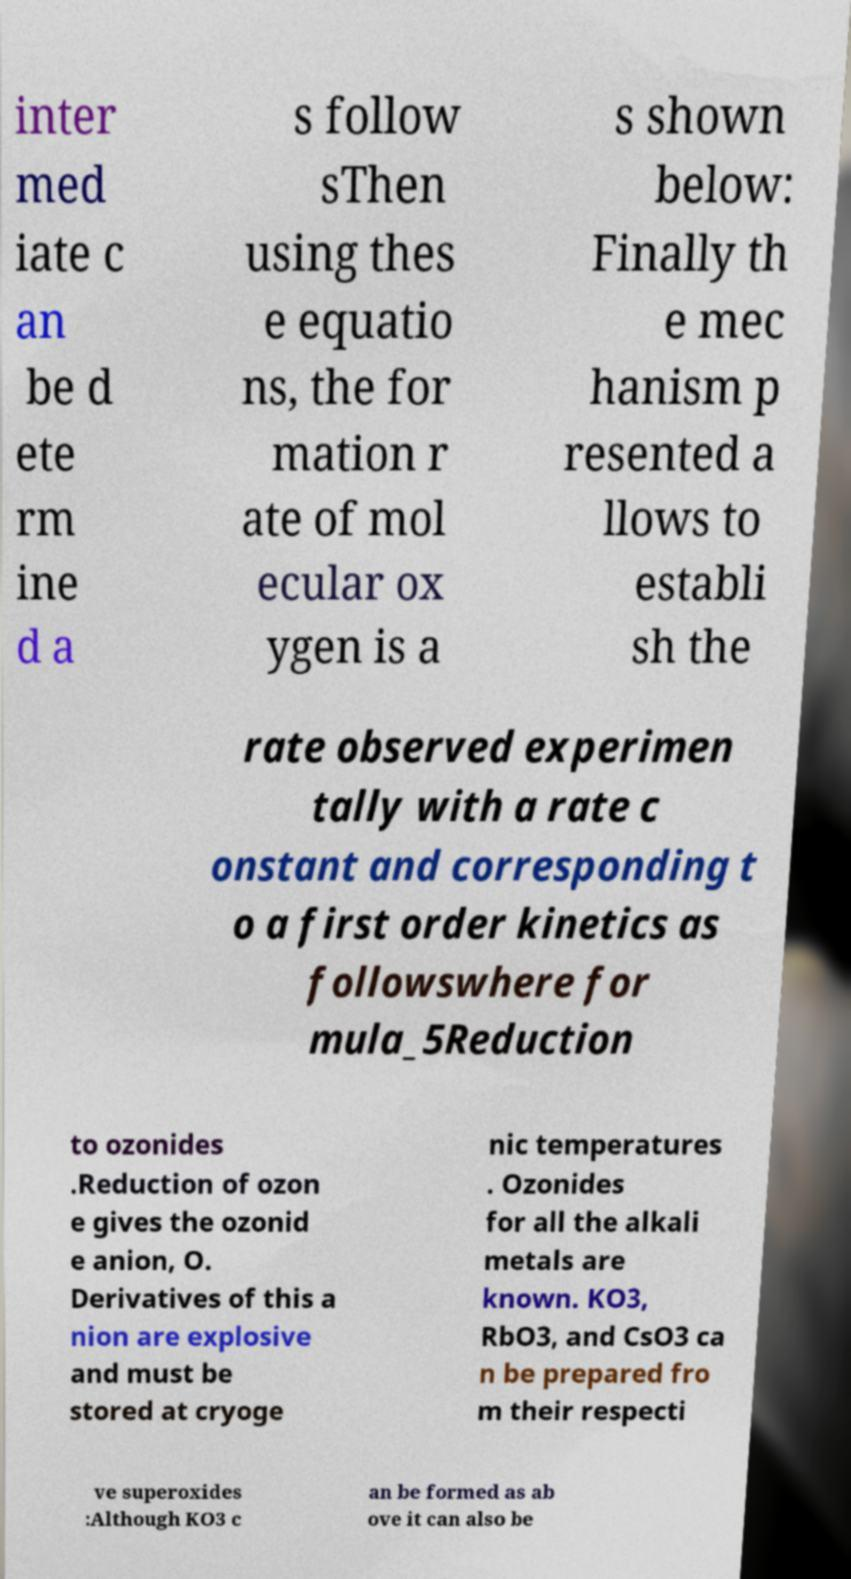Could you extract and type out the text from this image? inter med iate c an be d ete rm ine d a s follow sThen using thes e equatio ns, the for mation r ate of mol ecular ox ygen is a s shown below: Finally th e mec hanism p resented a llows to establi sh the rate observed experimen tally with a rate c onstant and corresponding t o a first order kinetics as followswhere for mula_5Reduction to ozonides .Reduction of ozon e gives the ozonid e anion, O. Derivatives of this a nion are explosive and must be stored at cryoge nic temperatures . Ozonides for all the alkali metals are known. KO3, RbO3, and CsO3 ca n be prepared fro m their respecti ve superoxides :Although KO3 c an be formed as ab ove it can also be 